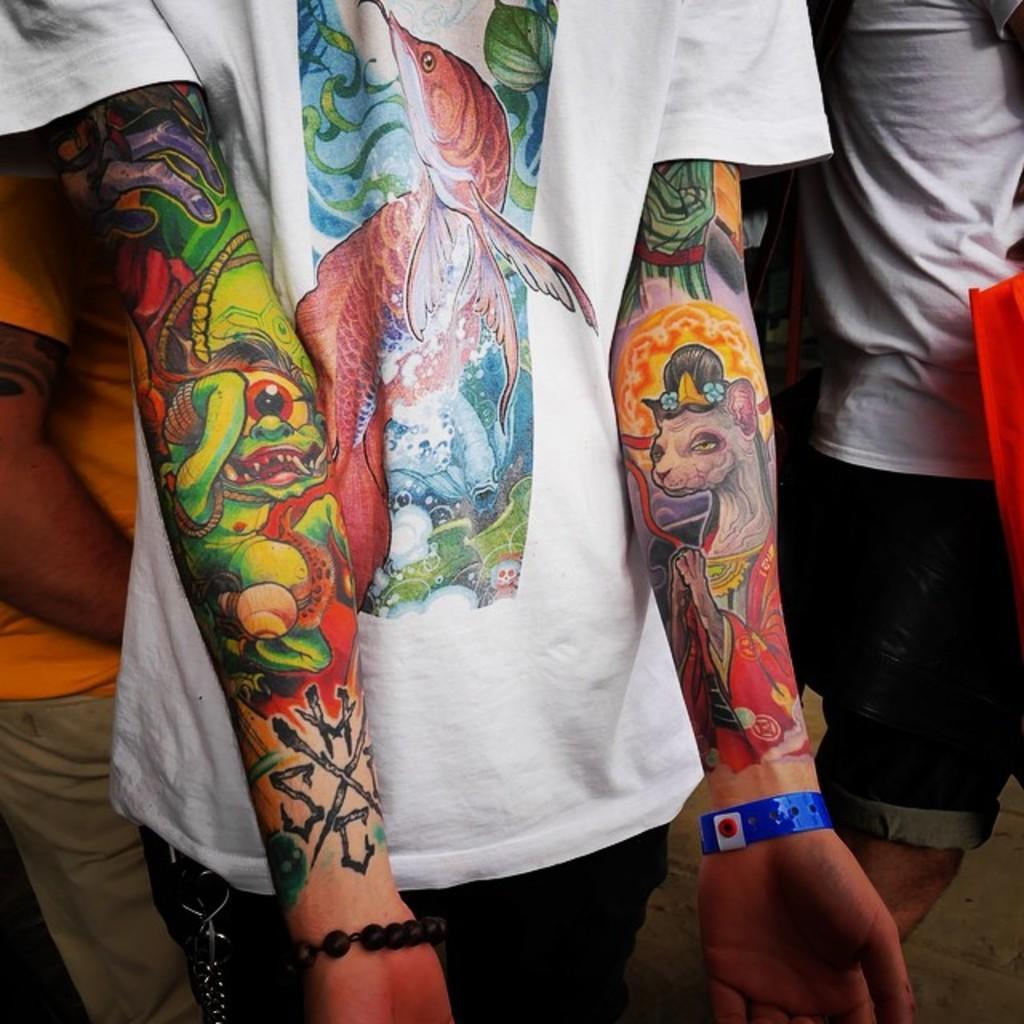Please provide a concise description of this image. Here in this picture we can see a person standing over a place and we can see tattoos and both the hands present over there and we can also see other people standing on the floor over there. 